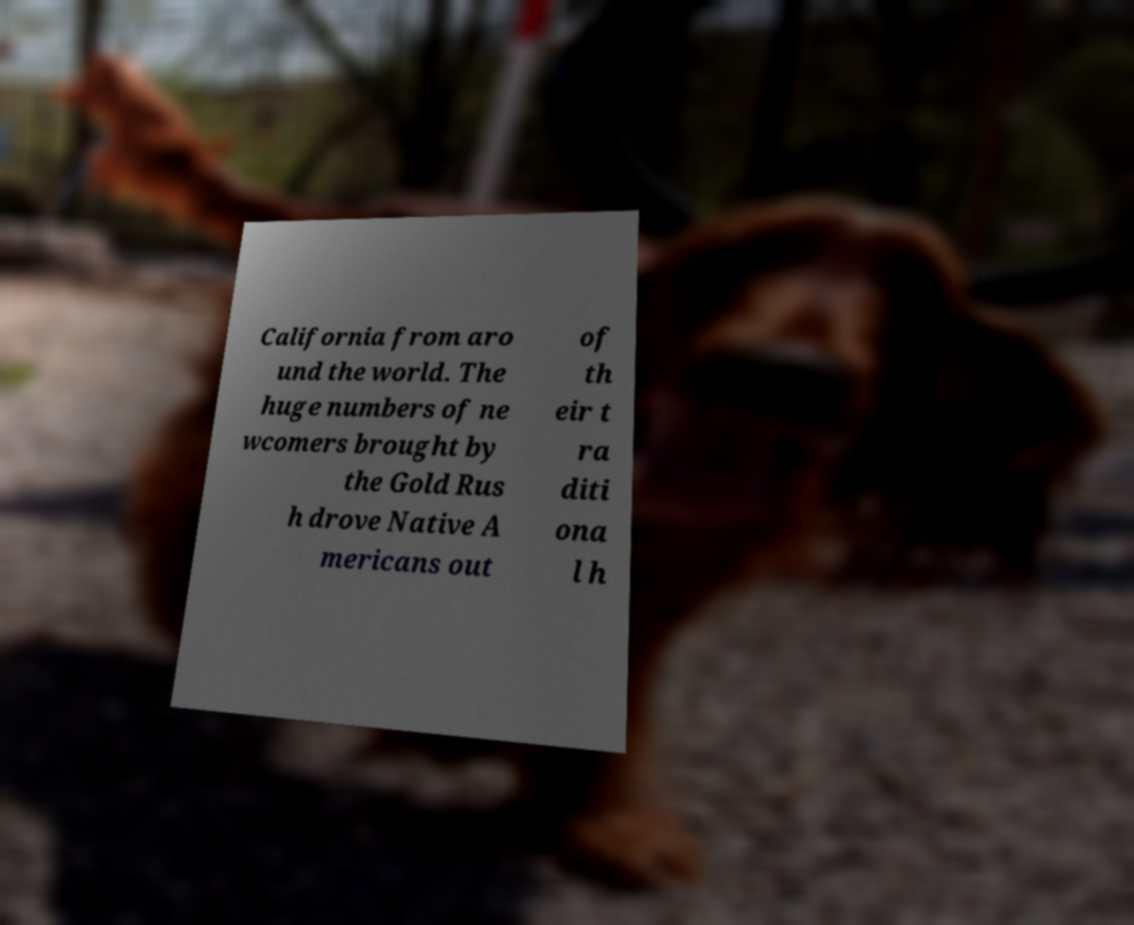What messages or text are displayed in this image? I need them in a readable, typed format. California from aro und the world. The huge numbers of ne wcomers brought by the Gold Rus h drove Native A mericans out of th eir t ra diti ona l h 